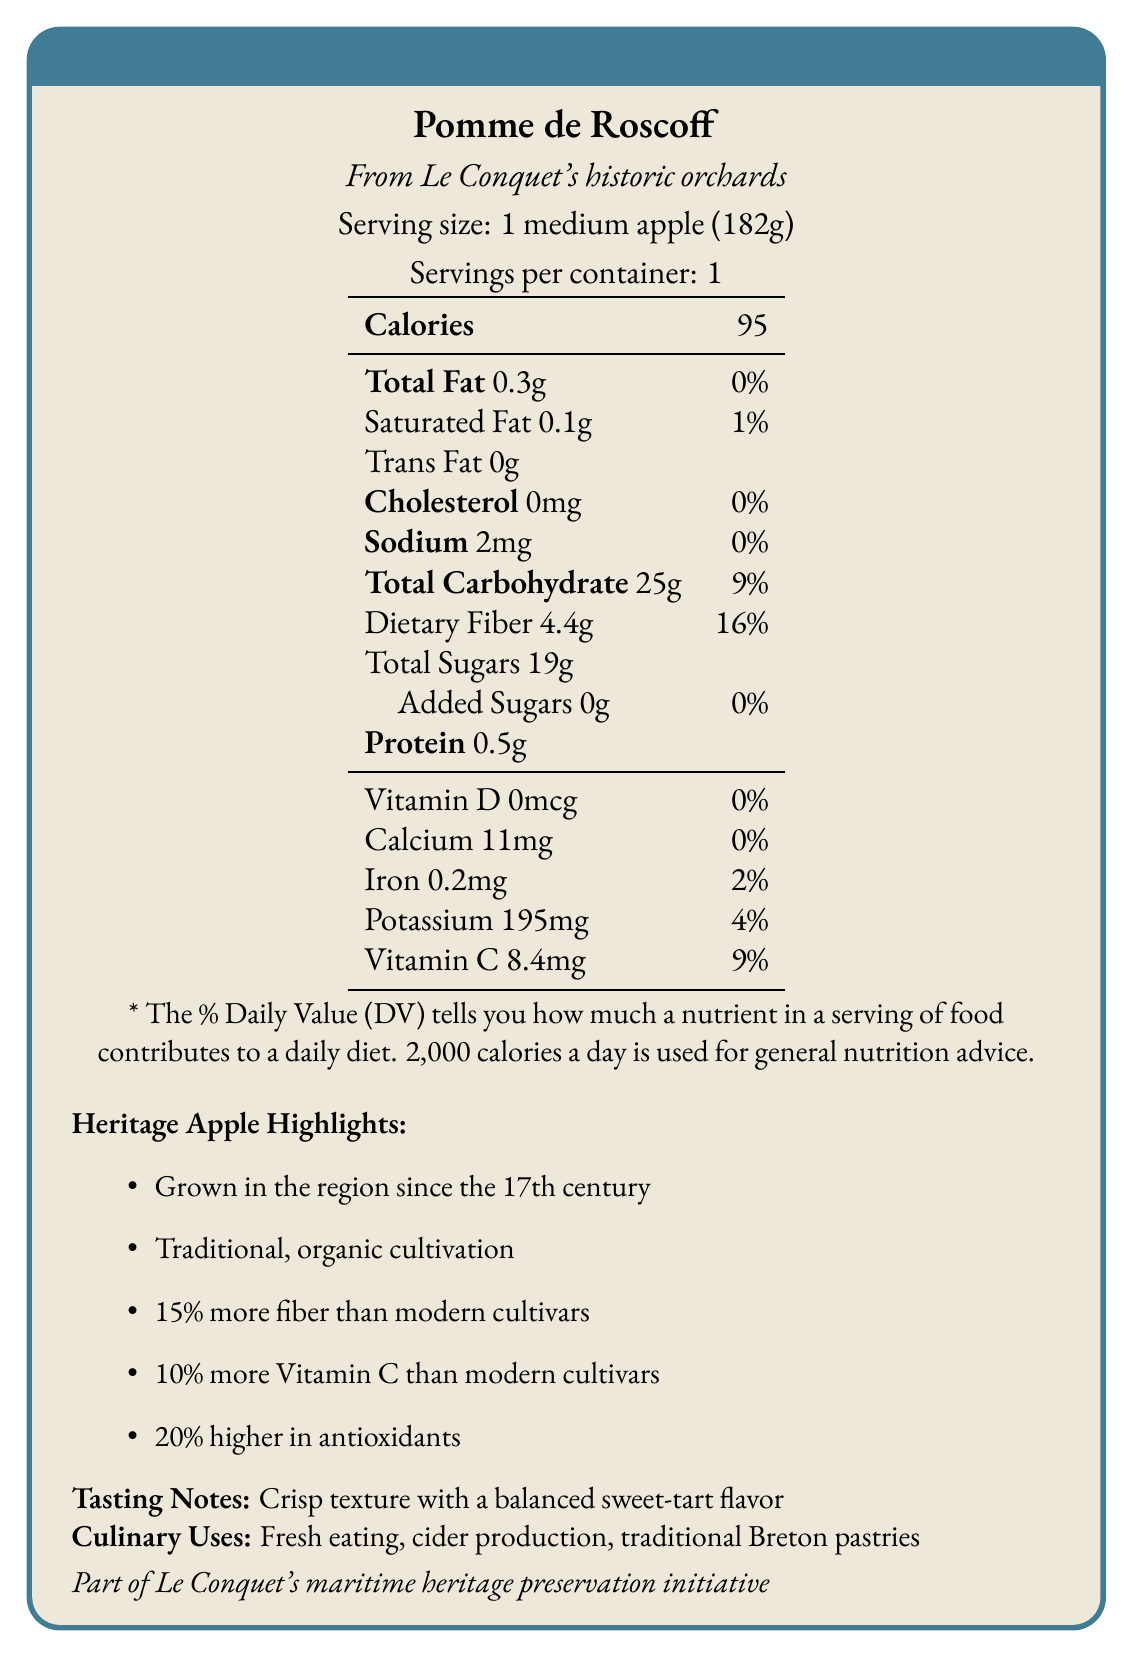what is the serving size of Pomme de Roscoff? The document states that the serving size is 1 medium apple, weighing 182 grams.
Answer: 1 medium apple (182g) how many calories are in a medium apple of Pomme de Roscoff? The document specifies that there are 95 calories in one serving, which is a medium apple.
Answer: 95 what is the total fat content in a serving of Pomme de Roscoff? The document lists the total fat content as 0.3 grams per serving.
Answer: 0.3g how much dietary fiber does Pomme de Roscoff contain? The document indicates that there are 4.4 grams of dietary fiber in a serving of Pomme de Roscoff.
Answer: 4.4g how does the fiber content of Pomme de Roscoff compare to modern cultivars? The document highlights that Pomme de Roscoff contains 15% more fiber than modern cultivars.
Answer: +15% which vitamin is present in the highest amount in Pomme de Roscoff? A. Vitamin D B. Calcium C. Iron D. Vitamin C According to the document, Vitamin C is present in the highest amount at 8.4 mg per serving.
Answer: D. Vitamin C how is the Pomme de Roscoff cultivated? A. Conventional farming B. Hydroponic methods C. Traditional, organic methods D. Genetically modified techniques The document mentions that Pomme de Roscoff is cultivated using traditional, organic methods.
Answer: C. Traditional, organic methods true or false: Pomme de Roscoff contains added sugars. The document clearly states that Pomme de Roscoff contains 0 grams of added sugars.
Answer: False summarize the key nutritional and historical highlights of Pomme de Roscoff. This summary captures the main nutritional facts and historical significance mentioned in the document.
Answer: Pomme de Roscoff is a heritage apple variety grown in Le Conquet's historic orchards since the 17th century. A medium apple contains 95 calories, 0.3g of total fat, 25g of carbohydrates, 4.4g of dietary fiber, and 19g of sugars. It has higher fiber (+15%), Vitamin C (+10%), and antioxidant content (+20%) than modern cultivars. It's cultivated traditionally and organically, with uses including fresh eating, cider production, and traditional Breton pastries. what is the protein content in a serving of Pomme de Roscoff? The document states that a serving of Pomme de Roscoff contains 0.5 grams of protein.
Answer: 0.5g what is the culinary significance of Pomme de Roscoff? The document lists fresh eating, cider production, and traditional Breton pastries as the culinary uses for Pomme de Roscoff.
Answer: Pomme de Roscoff is used for fresh eating, cider production, and traditional Breton pastries. what is the relationship between Pomme de Roscoff and Le Conquet's maritime heritage? The document mentions that Pomme de Roscoff is part of the maritime heritage preservation initiative in Le Conquet.
Answer: Part of Le Conquet's maritime heritage preservation initiative. which nutrient has no daily value percentage listed in the document? A. Vitamin D B. Calcium C. Iron D. Potassium Vitamin D has a value of 0 mcg and is listed with 0% daily value, indicating it's not contributing any significant daily nutritional value.
Answer: A. Vitamin D what is the traditional and historical cultivation method of Pomme de Roscoff? The document specifies that the Pomme de Roscoff is cultivated using traditional, organic methods.
Answer: Traditional, organic what is the crunchy texture of Pomme de Roscoff associated with based on the document? The document describes the Pomme de Roscoff as having a crisp texture with a balanced sweet-tart flavor.
Answer: Crisp texture with a balanced sweet-tart flavor how much sodium is in a serving of Pomme de Roscoff? The document states that there are 2 milligrams of sodium in a serving of Pomme de Roscoff.
Answer: 2mg how much higher in antioxidants is Pomme de Roscoff compared to modern cultivars? The document mentions that Pomme de Roscoff has 20% higher antioxidant content compared to modern cultivars.
Answer: +20% what historical significance does Pomme de Roscoff hold? The document notes that Pomme de Roscoff has been grown in the Le Conquet region since the 17th century.
Answer: Grown in the region since the 17th century. what are the specific conservation efforts mentioned in the document regarding Pomme de Roscoff? The document highlights that conservation efforts for Pomme de Roscoff are part of Le Conquet's maritime heritage preservation initiative.
Answer: Part of Le Conquet's maritime heritage preservation initiative what is the percentage of daily value for total carbohydrate in Pomme de Roscoff? The document states that the total carbohydrate content in a Pomme de Roscoff apple accounts for 9% of the daily value.
Answer: 9% what is the origin of Pomme de Roscoff? The document mentions that the Pomme de Roscoff comes from Le Conquet's historic orchards.
Answer: Le Conquet's historic orchards how much iron does a serving of Pomme de Roscoff contain? The document specifies that a serving of Pomme de Roscoff contains 0.2 milligrams of iron.
Answer: 0.2mg what is excluded from the tasting notes described in the document: Crisp texture, Juicy, or Sweet-tart flavor? The document only mentions a "crisp texture with a balanced sweet-tart flavor" in the tasting notes and does not mention "juicy".
Answer: Juicy 